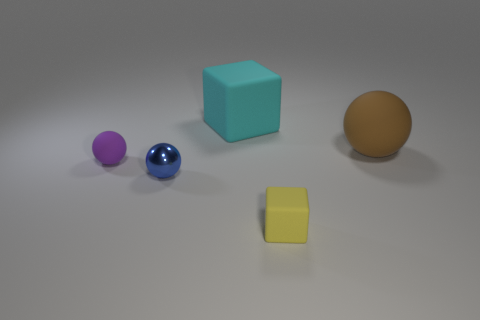Are there any purple matte objects of the same shape as the yellow thing?
Offer a very short reply. No. Is the size of the cube that is behind the tiny cube the same as the matte sphere that is on the right side of the big cyan block?
Provide a succinct answer. Yes. Is the number of shiny objects greater than the number of tiny balls?
Your answer should be compact. No. How many tiny purple things are the same material as the tiny yellow cube?
Offer a terse response. 1. Do the tiny shiny thing and the yellow object have the same shape?
Your answer should be compact. No. How big is the cube to the right of the matte block that is behind the tiny object in front of the blue metallic sphere?
Ensure brevity in your answer.  Small. Is there a small yellow thing in front of the cube that is on the right side of the big cyan cube?
Your response must be concise. No. What number of small purple matte objects are in front of the small rubber object that is left of the matte thing behind the brown rubber thing?
Your answer should be compact. 0. What is the color of the object that is both on the left side of the tiny matte block and on the right side of the small blue sphere?
Provide a short and direct response. Cyan. What number of small cubes are the same color as the shiny thing?
Your response must be concise. 0. 